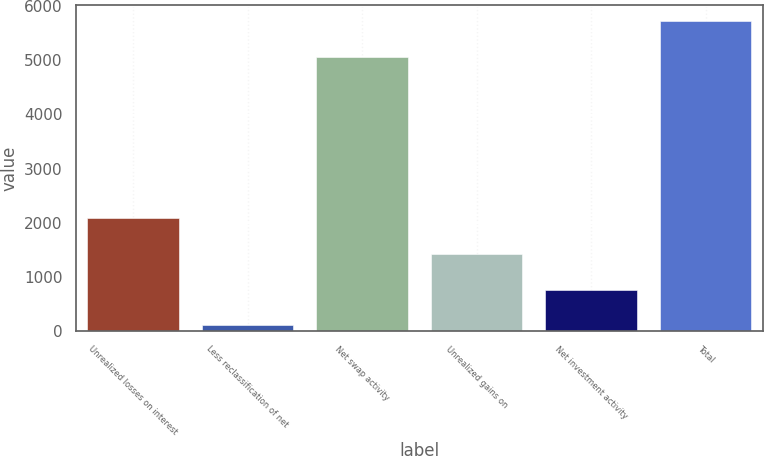Convert chart to OTSL. <chart><loc_0><loc_0><loc_500><loc_500><bar_chart><fcel>Unrealized losses on interest<fcel>Less reclassification of net<fcel>Net swap activity<fcel>Unrealized gains on<fcel>Net investment activity<fcel>Total<nl><fcel>2084.7<fcel>102<fcel>5069<fcel>1423.8<fcel>762.9<fcel>5729.9<nl></chart> 